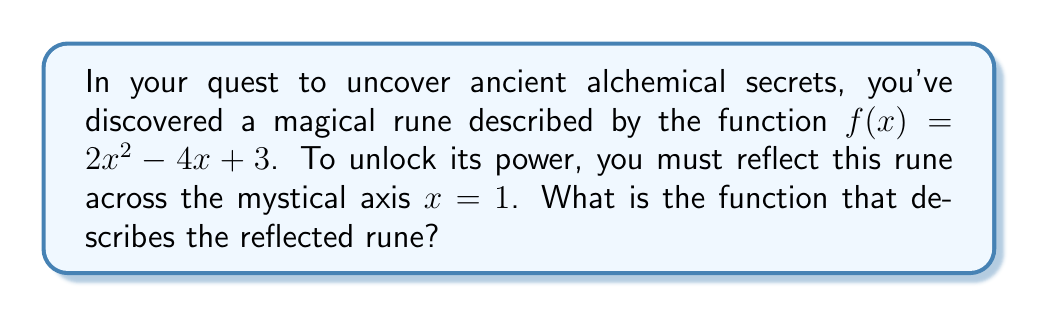What is the answer to this math problem? To reflect the function $f(x) = 2x^2 - 4x + 3$ across the vertical line $x = 1$, we follow these alchemical steps:

1) First, we need to understand that reflecting across $x = 1$ means replacing every $x$ in the original function with $(2 - x)$. This is because for any point $(a, b)$ on the original function, its reflection will be at $(2-a, b)$.

2) Let's call our new reflected function $g(x)$. We replace every $x$ in $f(x)$ with $(2-x)$:

   $g(x) = 2(2-x)^2 - 4(2-x) + 3$

3) Now, we expand the squared term:
   
   $g(x) = 2(4-4x+x^2) - 4(2-x) + 3$

4) Distribute the 2:
   
   $g(x) = 8-8x+2x^2 - 8+4x + 3$

5) Simplify by combining like terms:
   
   $g(x) = 2x^2 - 4x + 3$

6) Surprisingly, we end up with the same function we started with! This is because the parabola is symmetric about its axis of symmetry, which happens to be $x = 1$ in this case.
Answer: $g(x) = 2x^2 - 4x + 3$ 